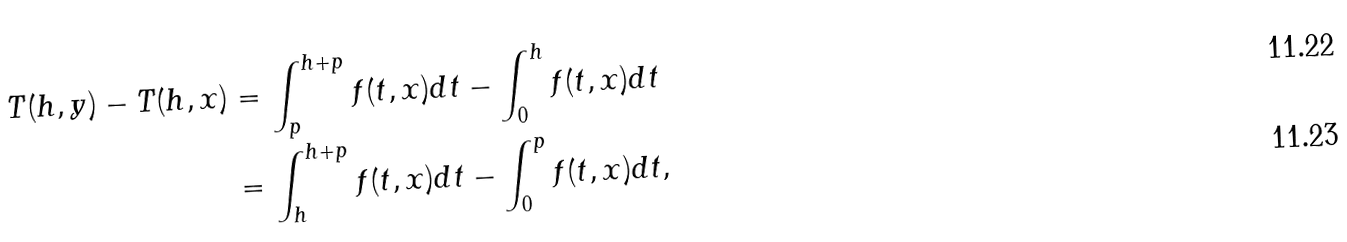Convert formula to latex. <formula><loc_0><loc_0><loc_500><loc_500>T ( h , y ) - T ( h , x ) & = \int _ { p } ^ { h + p } f ( t , x ) d t - \int _ { 0 } ^ { h } f ( t , x ) d t \\ & = \int _ { h } ^ { h + p } f ( t , x ) d t - \int _ { 0 } ^ { p } f ( t , x ) d t ,</formula> 